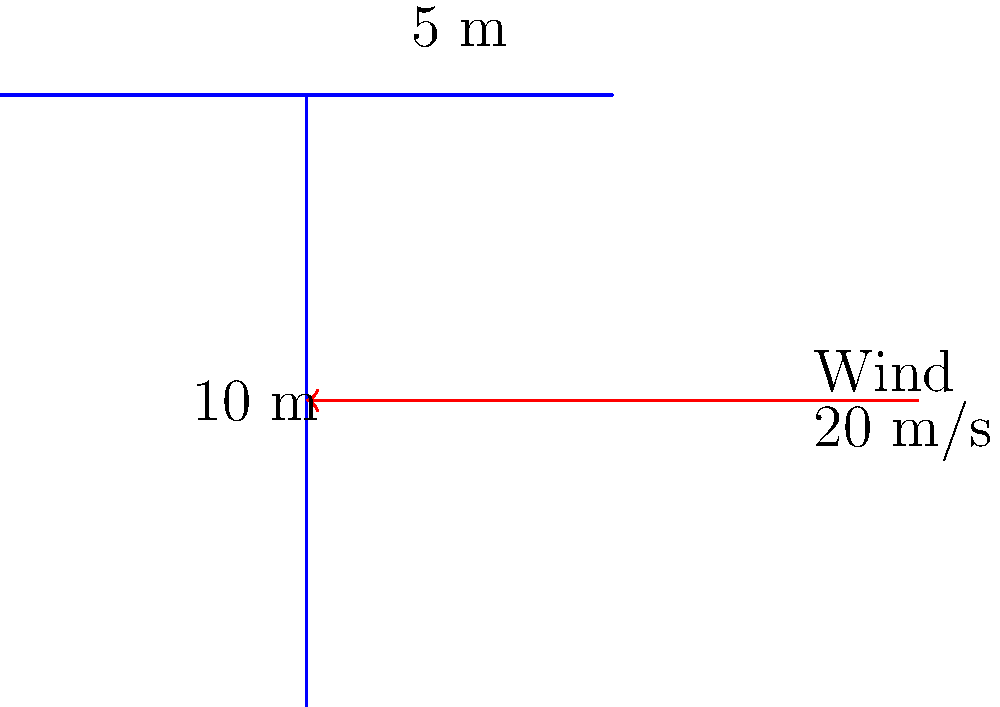As a wide receiver, you're analyzing the stability of the goalpost structure during windy conditions. Given a wind speed of 20 m/s perpendicular to the goalpost, estimate the total wind load on the structure. Assume the goalpost is 10 m tall with a 5 m wide crossbar, and use a drag coefficient of 1.2 for a rectangular cross-section. The air density is 1.225 kg/m³. How would this wind load compare to the force needed to tackle a linebacker? To estimate the wind load on the goalpost, we'll use the formula for wind pressure and then calculate the total force. Here's the step-by-step process:

1) Wind pressure formula: 
   $$P = \frac{1}{2} \cdot C_d \cdot \rho \cdot v^2$$
   Where:
   $P$ = wind pressure
   $C_d$ = drag coefficient (1.2 for rectangular cross-section)
   $\rho$ = air density (1.225 kg/m³)
   $v$ = wind velocity (20 m/s)

2) Calculate wind pressure:
   $$P = \frac{1}{2} \cdot 1.2 \cdot 1.225 \cdot 20^2 = 294 \text{ Pa}$$

3) Calculate the area of the goalpost:
   Vertical post: $10 \text{ m} \cdot 0.1 \text{ m} = 1 \text{ m}^2$
   Horizontal bar: $5 \text{ m} \cdot 0.1 \text{ m} = 0.5 \text{ m}^2$
   Total area: $1.5 \text{ m}^2$

4) Calculate total wind force:
   $$F = P \cdot A = 294 \text{ Pa} \cdot 1.5 \text{ m}^2 = 441 \text{ N}$$

5) Convert to a more relatable unit:
   $$441 \text{ N} \approx 45 \text{ kg} \cdot 9.81 \text{ m/s}^2 \approx 45 \text{ kg}$$

The wind load on the goalpost is equivalent to about 45 kg of force. This is comparable to tackling a lighter linebacker, showcasing the significant force that wind can exert on structures. As a wide receiver, you can appreciate how this force relates to the physical demands of football, emphasizing the importance of structural engineering in sports facility design.
Answer: 441 N or ~45 kg-force 